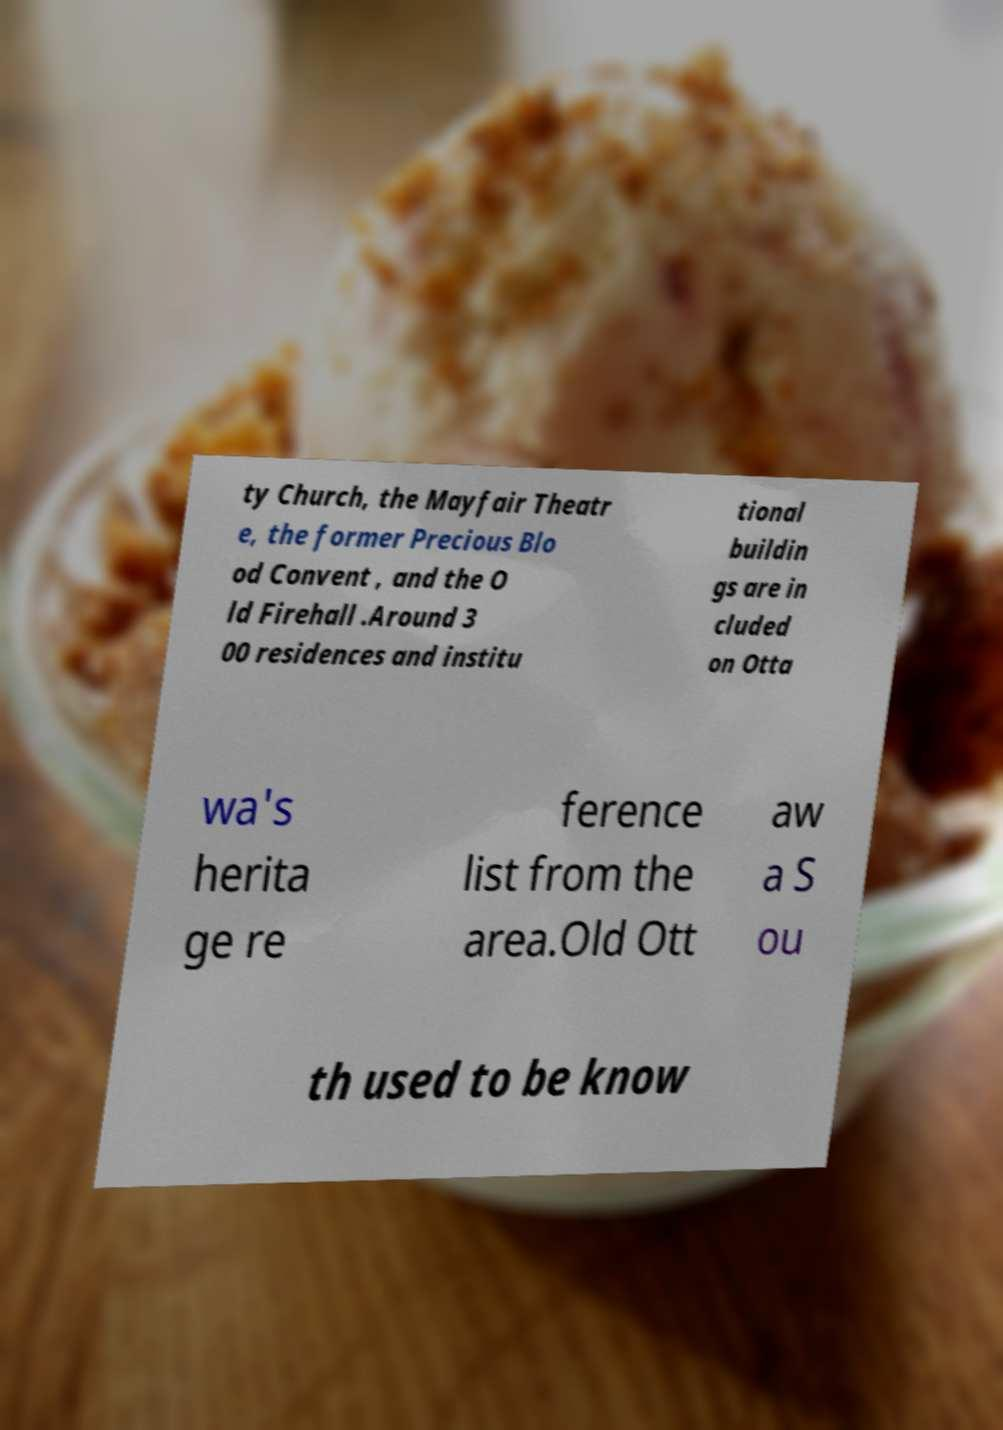What messages or text are displayed in this image? I need them in a readable, typed format. ty Church, the Mayfair Theatr e, the former Precious Blo od Convent , and the O ld Firehall .Around 3 00 residences and institu tional buildin gs are in cluded on Otta wa's herita ge re ference list from the area.Old Ott aw a S ou th used to be know 